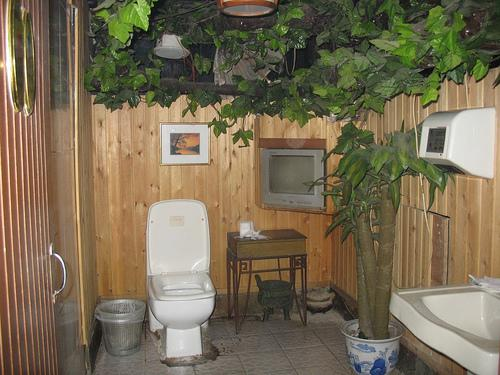Question: where is the picture?
Choices:
A. The bathroom.
B. Kitchen.
C. Beach.
D. Mountains.
Answer with the letter. Answer: A Question: what is green?
Choices:
A. Grass.
B. His shirt.
C. Her dress.
D. Trees.
Answer with the letter. Answer: D Question: how many toilets?
Choices:
A. Two.
B. Three.
C. Four.
D. One.
Answer with the letter. Answer: D Question: what has a plastic bag?
Choices:
A. Grocery shopper.
B. Litter collector.
C. Waste basket.
D. Trick or treater.
Answer with the letter. Answer: C Question: what is in a pot?
Choices:
A. Chicken.
B. A tree.
C. Water.
D. Soup.
Answer with the letter. Answer: B Question: why use the sink?
Choices:
A. I brush teeth.
B. To freshen up the face.
C. To wash hands.
D. To soak finger nails.
Answer with the letter. Answer: C Question: what is the dryer for?
Choices:
A. To dry hair.
B. To dry laundry.
C. To dry wet objects.
D. To dry hands.
Answer with the letter. Answer: D Question: where is there wood?
Choices:
A. In the floor.
B. On the wall.
C. By the fireplace.
D. Outside the cottage.
Answer with the letter. Answer: B 